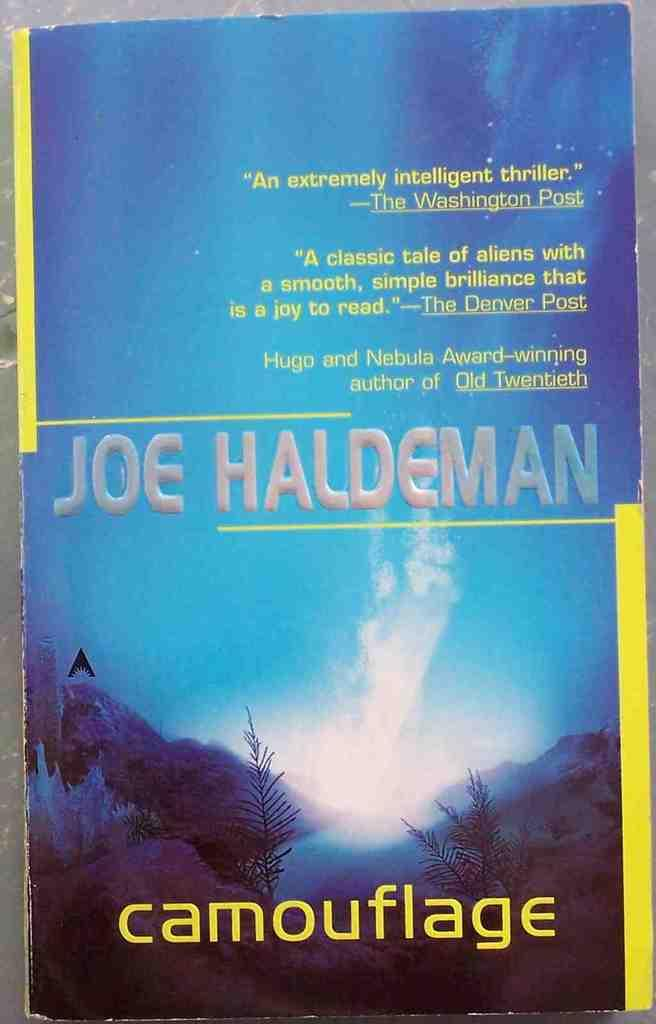<image>
Describe the image concisely. the cover of Joe Haldeman's blue and yellow book Camouflage 